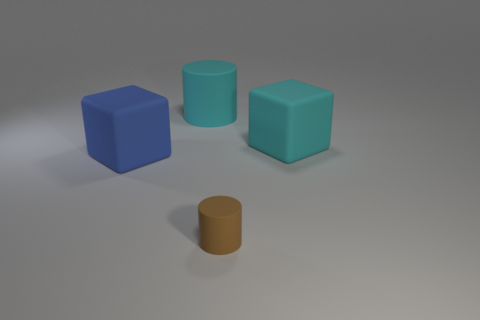There is a big object that is the same color as the large matte cylinder; what is it made of?
Offer a terse response. Rubber. Are there fewer small gray shiny blocks than matte blocks?
Keep it short and to the point. Yes. Is the color of the large thing that is to the right of the cyan cylinder the same as the big cylinder?
Provide a short and direct response. Yes. There is a small thing that is the same material as the blue cube; what is its color?
Your answer should be compact. Brown. Do the blue object and the brown matte thing have the same size?
Provide a short and direct response. No. What is the large cylinder made of?
Give a very brief answer. Rubber. What is the material of the blue thing that is the same size as the cyan rubber cube?
Give a very brief answer. Rubber. Is there a blue block that has the same size as the cyan rubber cylinder?
Make the answer very short. Yes. Are there the same number of tiny things that are on the right side of the small object and big matte objects that are in front of the cyan cylinder?
Keep it short and to the point. No. Is the number of large blue matte things greater than the number of rubber cylinders?
Provide a succinct answer. No. 